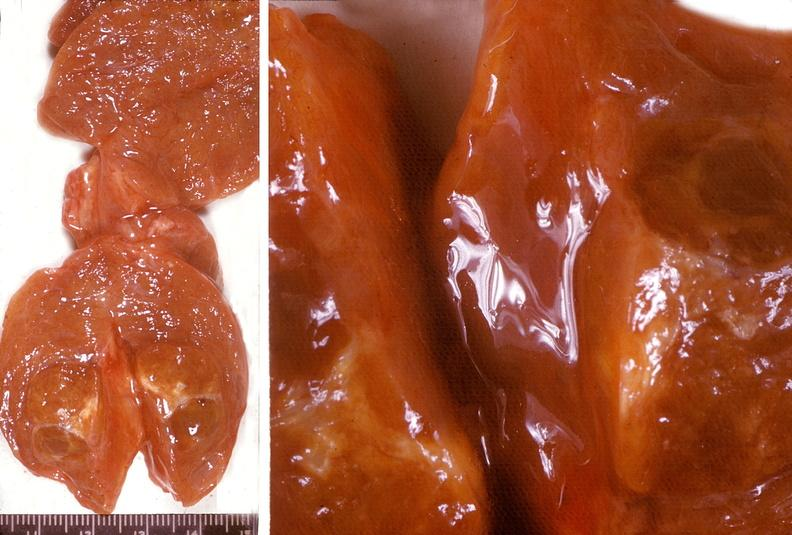what is present?
Answer the question using a single word or phrase. Endocrine 